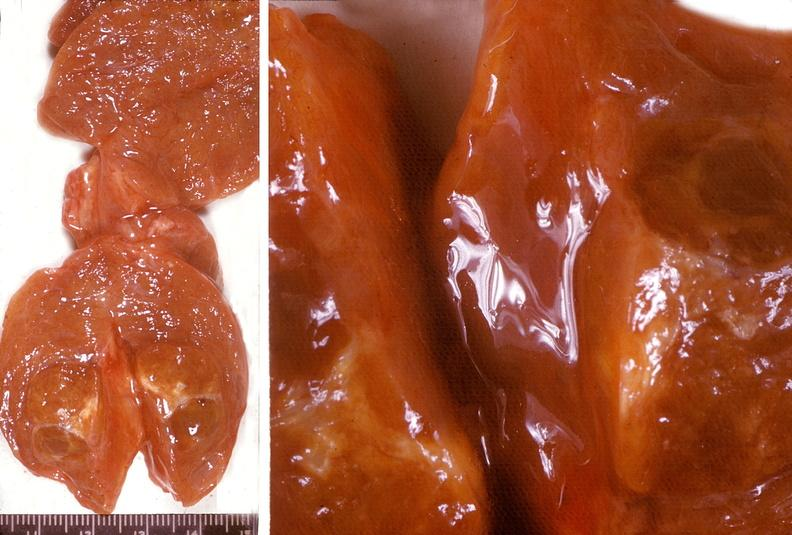what is present?
Answer the question using a single word or phrase. Endocrine 